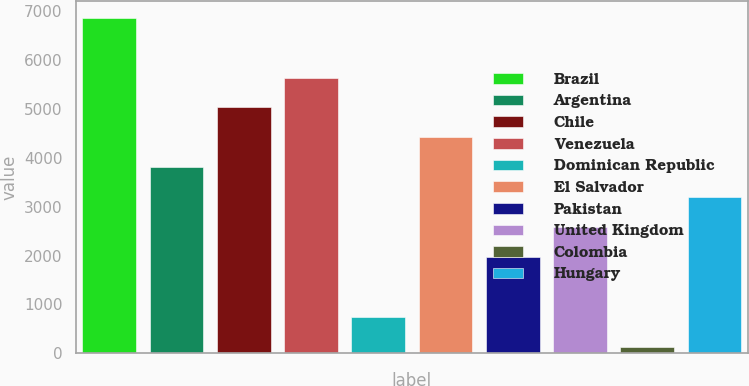Convert chart to OTSL. <chart><loc_0><loc_0><loc_500><loc_500><bar_chart><fcel>Brazil<fcel>Argentina<fcel>Chile<fcel>Venezuela<fcel>Dominican Republic<fcel>El Salvador<fcel>Pakistan<fcel>United Kingdom<fcel>Colombia<fcel>Hungary<nl><fcel>6869.4<fcel>3807.4<fcel>5032.2<fcel>5644.6<fcel>745.4<fcel>4419.8<fcel>1970.2<fcel>2582.6<fcel>133<fcel>3195<nl></chart> 